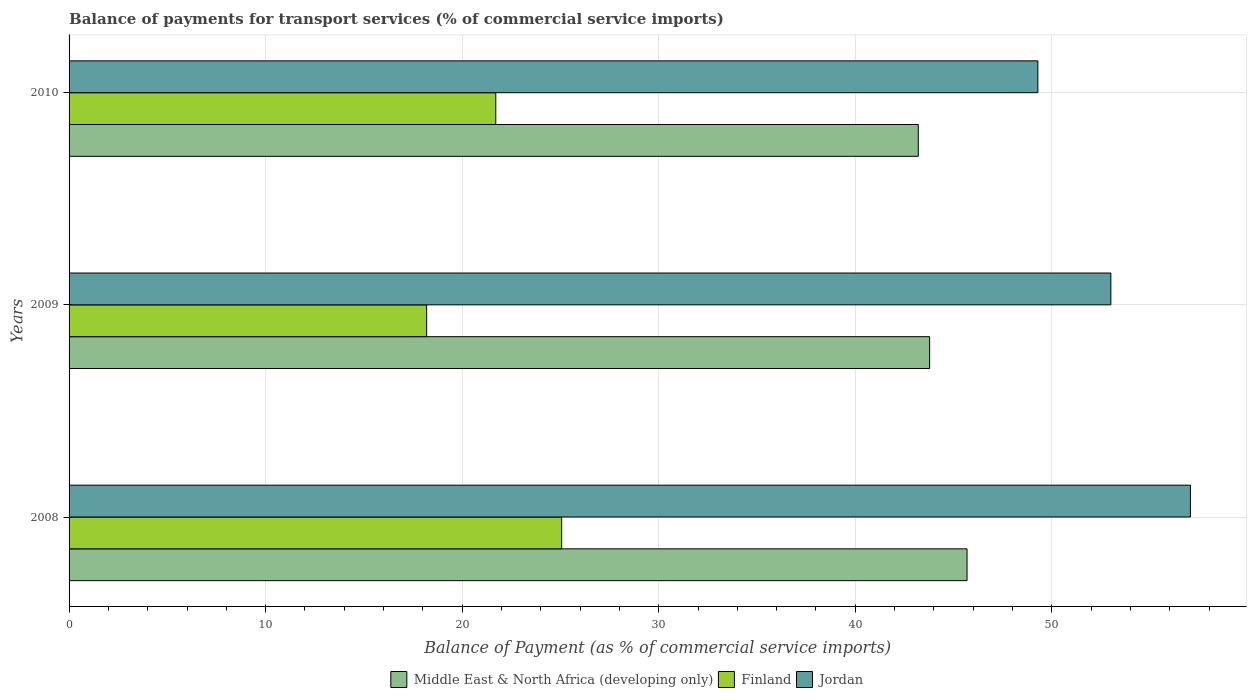How many different coloured bars are there?
Provide a succinct answer. 3. How many groups of bars are there?
Your answer should be compact. 3. How many bars are there on the 2nd tick from the top?
Offer a very short reply. 3. What is the label of the 3rd group of bars from the top?
Give a very brief answer. 2008. What is the balance of payments for transport services in Finland in 2008?
Give a very brief answer. 25.06. Across all years, what is the maximum balance of payments for transport services in Finland?
Your response must be concise. 25.06. Across all years, what is the minimum balance of payments for transport services in Jordan?
Offer a terse response. 49.29. In which year was the balance of payments for transport services in Finland maximum?
Offer a terse response. 2008. What is the total balance of payments for transport services in Jordan in the graph?
Your answer should be very brief. 159.35. What is the difference between the balance of payments for transport services in Jordan in 2008 and that in 2010?
Your answer should be very brief. 7.76. What is the difference between the balance of payments for transport services in Finland in 2010 and the balance of payments for transport services in Middle East & North Africa (developing only) in 2008?
Make the answer very short. -23.98. What is the average balance of payments for transport services in Middle East & North Africa (developing only) per year?
Keep it short and to the point. 44.23. In the year 2008, what is the difference between the balance of payments for transport services in Finland and balance of payments for transport services in Middle East & North Africa (developing only)?
Your response must be concise. -20.63. What is the ratio of the balance of payments for transport services in Jordan in 2008 to that in 2010?
Offer a very short reply. 1.16. Is the difference between the balance of payments for transport services in Finland in 2009 and 2010 greater than the difference between the balance of payments for transport services in Middle East & North Africa (developing only) in 2009 and 2010?
Offer a very short reply. No. What is the difference between the highest and the second highest balance of payments for transport services in Jordan?
Give a very brief answer. 4.05. What is the difference between the highest and the lowest balance of payments for transport services in Middle East & North Africa (developing only)?
Ensure brevity in your answer.  2.48. In how many years, is the balance of payments for transport services in Middle East & North Africa (developing only) greater than the average balance of payments for transport services in Middle East & North Africa (developing only) taken over all years?
Offer a very short reply. 1. Is the sum of the balance of payments for transport services in Middle East & North Africa (developing only) in 2008 and 2009 greater than the maximum balance of payments for transport services in Finland across all years?
Make the answer very short. Yes. What does the 1st bar from the top in 2008 represents?
Ensure brevity in your answer.  Jordan. What does the 3rd bar from the bottom in 2008 represents?
Give a very brief answer. Jordan. Are all the bars in the graph horizontal?
Your response must be concise. Yes. How many years are there in the graph?
Provide a short and direct response. 3. What is the difference between two consecutive major ticks on the X-axis?
Provide a succinct answer. 10. Does the graph contain any zero values?
Offer a terse response. No. Does the graph contain grids?
Offer a very short reply. Yes. How many legend labels are there?
Offer a terse response. 3. How are the legend labels stacked?
Provide a succinct answer. Horizontal. What is the title of the graph?
Your response must be concise. Balance of payments for transport services (% of commercial service imports). What is the label or title of the X-axis?
Provide a short and direct response. Balance of Payment (as % of commercial service imports). What is the Balance of Payment (as % of commercial service imports) in Middle East & North Africa (developing only) in 2008?
Your response must be concise. 45.69. What is the Balance of Payment (as % of commercial service imports) in Finland in 2008?
Offer a very short reply. 25.06. What is the Balance of Payment (as % of commercial service imports) in Jordan in 2008?
Keep it short and to the point. 57.05. What is the Balance of Payment (as % of commercial service imports) of Middle East & North Africa (developing only) in 2009?
Your response must be concise. 43.78. What is the Balance of Payment (as % of commercial service imports) in Finland in 2009?
Offer a very short reply. 18.19. What is the Balance of Payment (as % of commercial service imports) in Jordan in 2009?
Provide a succinct answer. 53.01. What is the Balance of Payment (as % of commercial service imports) of Middle East & North Africa (developing only) in 2010?
Keep it short and to the point. 43.21. What is the Balance of Payment (as % of commercial service imports) of Finland in 2010?
Offer a terse response. 21.71. What is the Balance of Payment (as % of commercial service imports) of Jordan in 2010?
Your response must be concise. 49.29. Across all years, what is the maximum Balance of Payment (as % of commercial service imports) of Middle East & North Africa (developing only)?
Ensure brevity in your answer.  45.69. Across all years, what is the maximum Balance of Payment (as % of commercial service imports) of Finland?
Provide a succinct answer. 25.06. Across all years, what is the maximum Balance of Payment (as % of commercial service imports) of Jordan?
Ensure brevity in your answer.  57.05. Across all years, what is the minimum Balance of Payment (as % of commercial service imports) in Middle East & North Africa (developing only)?
Make the answer very short. 43.21. Across all years, what is the minimum Balance of Payment (as % of commercial service imports) in Finland?
Ensure brevity in your answer.  18.19. Across all years, what is the minimum Balance of Payment (as % of commercial service imports) in Jordan?
Offer a terse response. 49.29. What is the total Balance of Payment (as % of commercial service imports) of Middle East & North Africa (developing only) in the graph?
Your answer should be compact. 132.68. What is the total Balance of Payment (as % of commercial service imports) in Finland in the graph?
Provide a short and direct response. 64.97. What is the total Balance of Payment (as % of commercial service imports) in Jordan in the graph?
Ensure brevity in your answer.  159.35. What is the difference between the Balance of Payment (as % of commercial service imports) in Middle East & North Africa (developing only) in 2008 and that in 2009?
Offer a terse response. 1.9. What is the difference between the Balance of Payment (as % of commercial service imports) of Finland in 2008 and that in 2009?
Provide a succinct answer. 6.87. What is the difference between the Balance of Payment (as % of commercial service imports) of Jordan in 2008 and that in 2009?
Make the answer very short. 4.05. What is the difference between the Balance of Payment (as % of commercial service imports) in Middle East & North Africa (developing only) in 2008 and that in 2010?
Provide a succinct answer. 2.48. What is the difference between the Balance of Payment (as % of commercial service imports) of Finland in 2008 and that in 2010?
Make the answer very short. 3.35. What is the difference between the Balance of Payment (as % of commercial service imports) in Jordan in 2008 and that in 2010?
Your answer should be compact. 7.76. What is the difference between the Balance of Payment (as % of commercial service imports) of Middle East & North Africa (developing only) in 2009 and that in 2010?
Your answer should be compact. 0.58. What is the difference between the Balance of Payment (as % of commercial service imports) in Finland in 2009 and that in 2010?
Ensure brevity in your answer.  -3.52. What is the difference between the Balance of Payment (as % of commercial service imports) in Jordan in 2009 and that in 2010?
Make the answer very short. 3.71. What is the difference between the Balance of Payment (as % of commercial service imports) of Middle East & North Africa (developing only) in 2008 and the Balance of Payment (as % of commercial service imports) of Finland in 2009?
Your response must be concise. 27.49. What is the difference between the Balance of Payment (as % of commercial service imports) in Middle East & North Africa (developing only) in 2008 and the Balance of Payment (as % of commercial service imports) in Jordan in 2009?
Offer a terse response. -7.32. What is the difference between the Balance of Payment (as % of commercial service imports) in Finland in 2008 and the Balance of Payment (as % of commercial service imports) in Jordan in 2009?
Make the answer very short. -27.94. What is the difference between the Balance of Payment (as % of commercial service imports) of Middle East & North Africa (developing only) in 2008 and the Balance of Payment (as % of commercial service imports) of Finland in 2010?
Offer a very short reply. 23.98. What is the difference between the Balance of Payment (as % of commercial service imports) in Middle East & North Africa (developing only) in 2008 and the Balance of Payment (as % of commercial service imports) in Jordan in 2010?
Provide a succinct answer. -3.6. What is the difference between the Balance of Payment (as % of commercial service imports) of Finland in 2008 and the Balance of Payment (as % of commercial service imports) of Jordan in 2010?
Your answer should be very brief. -24.23. What is the difference between the Balance of Payment (as % of commercial service imports) of Middle East & North Africa (developing only) in 2009 and the Balance of Payment (as % of commercial service imports) of Finland in 2010?
Provide a succinct answer. 22.07. What is the difference between the Balance of Payment (as % of commercial service imports) in Middle East & North Africa (developing only) in 2009 and the Balance of Payment (as % of commercial service imports) in Jordan in 2010?
Your response must be concise. -5.51. What is the difference between the Balance of Payment (as % of commercial service imports) in Finland in 2009 and the Balance of Payment (as % of commercial service imports) in Jordan in 2010?
Offer a very short reply. -31.1. What is the average Balance of Payment (as % of commercial service imports) of Middle East & North Africa (developing only) per year?
Ensure brevity in your answer.  44.23. What is the average Balance of Payment (as % of commercial service imports) of Finland per year?
Your answer should be very brief. 21.66. What is the average Balance of Payment (as % of commercial service imports) of Jordan per year?
Provide a short and direct response. 53.12. In the year 2008, what is the difference between the Balance of Payment (as % of commercial service imports) of Middle East & North Africa (developing only) and Balance of Payment (as % of commercial service imports) of Finland?
Your response must be concise. 20.63. In the year 2008, what is the difference between the Balance of Payment (as % of commercial service imports) in Middle East & North Africa (developing only) and Balance of Payment (as % of commercial service imports) in Jordan?
Your answer should be very brief. -11.37. In the year 2008, what is the difference between the Balance of Payment (as % of commercial service imports) in Finland and Balance of Payment (as % of commercial service imports) in Jordan?
Make the answer very short. -31.99. In the year 2009, what is the difference between the Balance of Payment (as % of commercial service imports) of Middle East & North Africa (developing only) and Balance of Payment (as % of commercial service imports) of Finland?
Provide a short and direct response. 25.59. In the year 2009, what is the difference between the Balance of Payment (as % of commercial service imports) of Middle East & North Africa (developing only) and Balance of Payment (as % of commercial service imports) of Jordan?
Offer a terse response. -9.22. In the year 2009, what is the difference between the Balance of Payment (as % of commercial service imports) of Finland and Balance of Payment (as % of commercial service imports) of Jordan?
Ensure brevity in your answer.  -34.81. In the year 2010, what is the difference between the Balance of Payment (as % of commercial service imports) of Middle East & North Africa (developing only) and Balance of Payment (as % of commercial service imports) of Finland?
Offer a terse response. 21.5. In the year 2010, what is the difference between the Balance of Payment (as % of commercial service imports) of Middle East & North Africa (developing only) and Balance of Payment (as % of commercial service imports) of Jordan?
Offer a terse response. -6.08. In the year 2010, what is the difference between the Balance of Payment (as % of commercial service imports) in Finland and Balance of Payment (as % of commercial service imports) in Jordan?
Your answer should be very brief. -27.58. What is the ratio of the Balance of Payment (as % of commercial service imports) in Middle East & North Africa (developing only) in 2008 to that in 2009?
Give a very brief answer. 1.04. What is the ratio of the Balance of Payment (as % of commercial service imports) of Finland in 2008 to that in 2009?
Your answer should be compact. 1.38. What is the ratio of the Balance of Payment (as % of commercial service imports) in Jordan in 2008 to that in 2009?
Keep it short and to the point. 1.08. What is the ratio of the Balance of Payment (as % of commercial service imports) of Middle East & North Africa (developing only) in 2008 to that in 2010?
Your answer should be very brief. 1.06. What is the ratio of the Balance of Payment (as % of commercial service imports) of Finland in 2008 to that in 2010?
Offer a terse response. 1.15. What is the ratio of the Balance of Payment (as % of commercial service imports) of Jordan in 2008 to that in 2010?
Ensure brevity in your answer.  1.16. What is the ratio of the Balance of Payment (as % of commercial service imports) of Middle East & North Africa (developing only) in 2009 to that in 2010?
Keep it short and to the point. 1.01. What is the ratio of the Balance of Payment (as % of commercial service imports) of Finland in 2009 to that in 2010?
Provide a succinct answer. 0.84. What is the ratio of the Balance of Payment (as % of commercial service imports) in Jordan in 2009 to that in 2010?
Your response must be concise. 1.08. What is the difference between the highest and the second highest Balance of Payment (as % of commercial service imports) in Middle East & North Africa (developing only)?
Your answer should be compact. 1.9. What is the difference between the highest and the second highest Balance of Payment (as % of commercial service imports) in Finland?
Offer a very short reply. 3.35. What is the difference between the highest and the second highest Balance of Payment (as % of commercial service imports) in Jordan?
Your answer should be very brief. 4.05. What is the difference between the highest and the lowest Balance of Payment (as % of commercial service imports) in Middle East & North Africa (developing only)?
Your response must be concise. 2.48. What is the difference between the highest and the lowest Balance of Payment (as % of commercial service imports) in Finland?
Give a very brief answer. 6.87. What is the difference between the highest and the lowest Balance of Payment (as % of commercial service imports) of Jordan?
Provide a short and direct response. 7.76. 